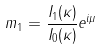Convert formula to latex. <formula><loc_0><loc_0><loc_500><loc_500>m _ { 1 } = \frac { I _ { 1 } ( \kappa ) } { I _ { 0 } ( \kappa ) } e ^ { i \mu }</formula> 